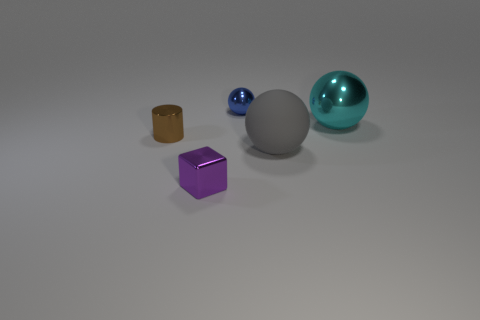Add 5 matte balls. How many objects exist? 10 Subtract all cylinders. How many objects are left? 4 Subtract 0 yellow blocks. How many objects are left? 5 Subtract all blue metal spheres. Subtract all tiny things. How many objects are left? 1 Add 1 rubber spheres. How many rubber spheres are left? 2 Add 1 large metallic things. How many large metallic things exist? 2 